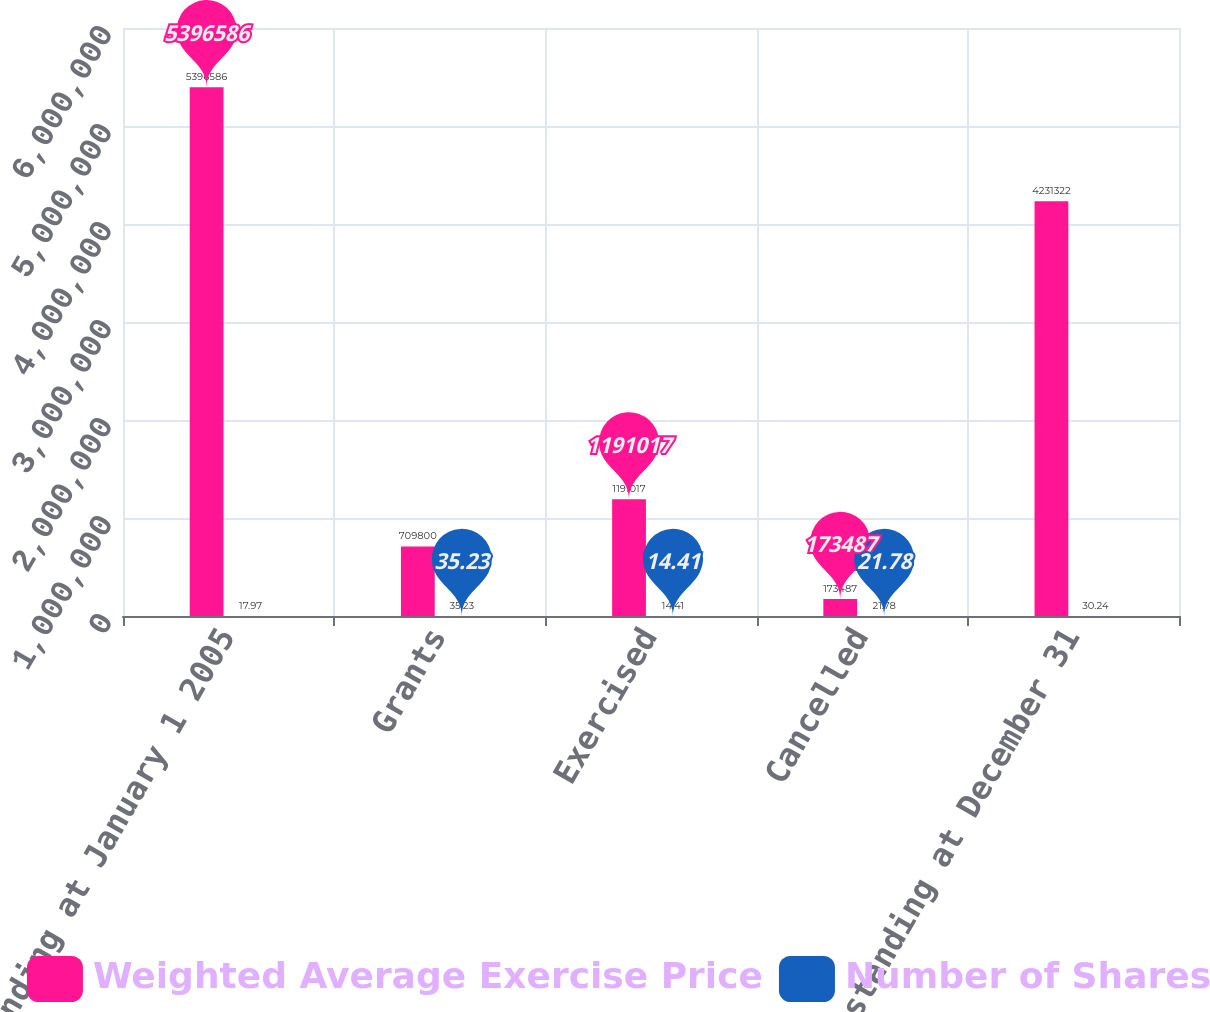Convert chart to OTSL. <chart><loc_0><loc_0><loc_500><loc_500><stacked_bar_chart><ecel><fcel>Outstanding at January 1 2005<fcel>Grants<fcel>Exercised<fcel>Cancelled<fcel>Outstanding at December 31<nl><fcel>Weighted Average Exercise Price<fcel>5.39659e+06<fcel>709800<fcel>1.19102e+06<fcel>173487<fcel>4.23132e+06<nl><fcel>Number of Shares<fcel>17.97<fcel>35.23<fcel>14.41<fcel>21.78<fcel>30.24<nl></chart> 